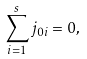Convert formula to latex. <formula><loc_0><loc_0><loc_500><loc_500>\sum _ { i = 1 } ^ { s } j _ { 0 i } = 0 ,</formula> 